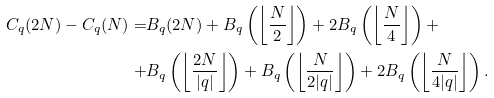<formula> <loc_0><loc_0><loc_500><loc_500>C _ { q } ( 2 N ) - C _ { q } ( N ) = & B _ { q } ( 2 N ) + B _ { q } \left ( \left \lfloor \frac { N } { 2 } \right \rfloor \right ) + 2 B _ { q } \left ( \left \lfloor \frac { N } { 4 } \right \rfloor \right ) + \\ + & B _ { q } \left ( \left \lfloor \frac { 2 N } { | q | } \right \rfloor \right ) + B _ { q } \left ( \left \lfloor \frac { N } { 2 | q | } \right \rfloor \right ) + 2 B _ { q } \left ( \left \lfloor \frac { N } { 4 | q | } \right \rfloor \right ) .</formula> 